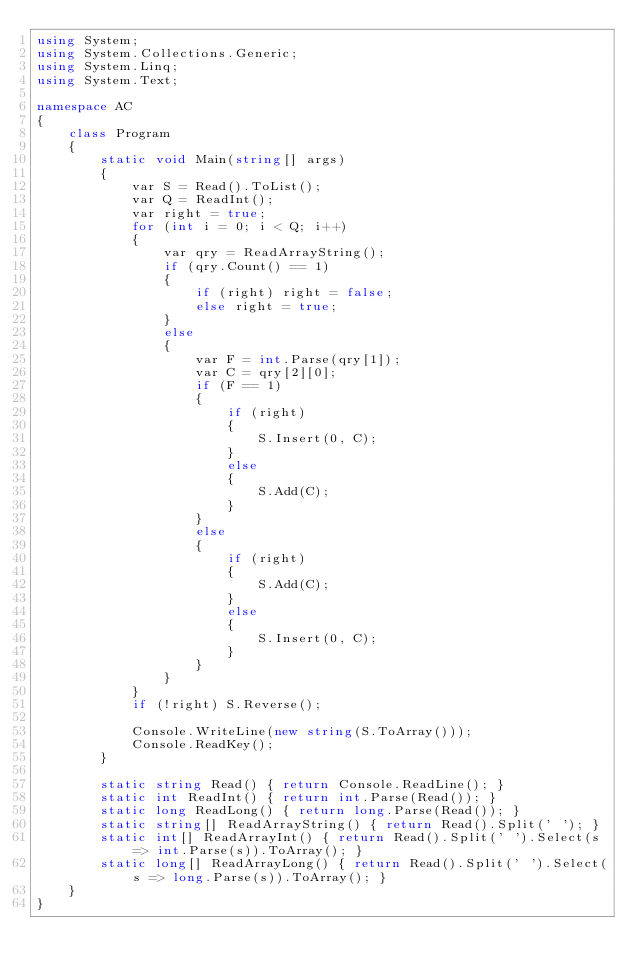<code> <loc_0><loc_0><loc_500><loc_500><_C#_>using System;
using System.Collections.Generic;
using System.Linq;
using System.Text;

namespace AC
{
    class Program
    {
        static void Main(string[] args)
        {
            var S = Read().ToList();
            var Q = ReadInt();
            var right = true;
            for (int i = 0; i < Q; i++)
            {
                var qry = ReadArrayString();
                if (qry.Count() == 1)
                {
                    if (right) right = false;
                    else right = true;
                }
                else
                {
                    var F = int.Parse(qry[1]);
                    var C = qry[2][0];
                    if (F == 1)
                    {
                        if (right)
                        {
                            S.Insert(0, C);
                        }
                        else
                        {
                            S.Add(C);
                        }
                    }
                    else
                    {
                        if (right)
                        {
                            S.Add(C);
                        }
                        else
                        {
                            S.Insert(0, C);
                        }
                    }
                }
            }
            if (!right) S.Reverse();

            Console.WriteLine(new string(S.ToArray()));
            Console.ReadKey();
        }

        static string Read() { return Console.ReadLine(); }
        static int ReadInt() { return int.Parse(Read()); }
        static long ReadLong() { return long.Parse(Read()); }
        static string[] ReadArrayString() { return Read().Split(' '); }
        static int[] ReadArrayInt() { return Read().Split(' ').Select(s => int.Parse(s)).ToArray(); }
        static long[] ReadArrayLong() { return Read().Split(' ').Select(s => long.Parse(s)).ToArray(); }
    }
}</code> 